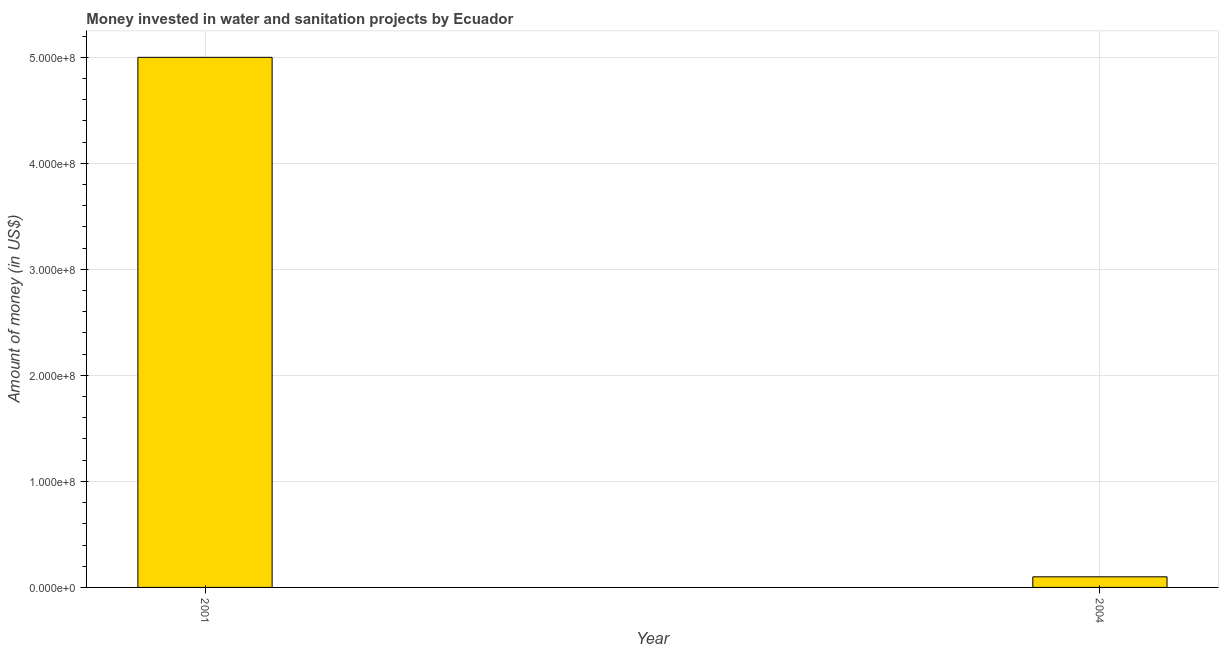What is the title of the graph?
Give a very brief answer. Money invested in water and sanitation projects by Ecuador. What is the label or title of the Y-axis?
Your answer should be very brief. Amount of money (in US$). Across all years, what is the maximum investment?
Ensure brevity in your answer.  5.00e+08. Across all years, what is the minimum investment?
Offer a very short reply. 1.00e+07. In which year was the investment maximum?
Give a very brief answer. 2001. In which year was the investment minimum?
Ensure brevity in your answer.  2004. What is the sum of the investment?
Your answer should be very brief. 5.10e+08. What is the difference between the investment in 2001 and 2004?
Offer a terse response. 4.90e+08. What is the average investment per year?
Offer a very short reply. 2.55e+08. What is the median investment?
Offer a terse response. 2.55e+08. Is the investment in 2001 less than that in 2004?
Your answer should be compact. No. In how many years, is the investment greater than the average investment taken over all years?
Provide a short and direct response. 1. How many bars are there?
Your answer should be compact. 2. How many years are there in the graph?
Provide a short and direct response. 2. What is the difference between two consecutive major ticks on the Y-axis?
Your answer should be very brief. 1.00e+08. Are the values on the major ticks of Y-axis written in scientific E-notation?
Give a very brief answer. Yes. What is the Amount of money (in US$) in 2004?
Give a very brief answer. 1.00e+07. What is the difference between the Amount of money (in US$) in 2001 and 2004?
Ensure brevity in your answer.  4.90e+08. 